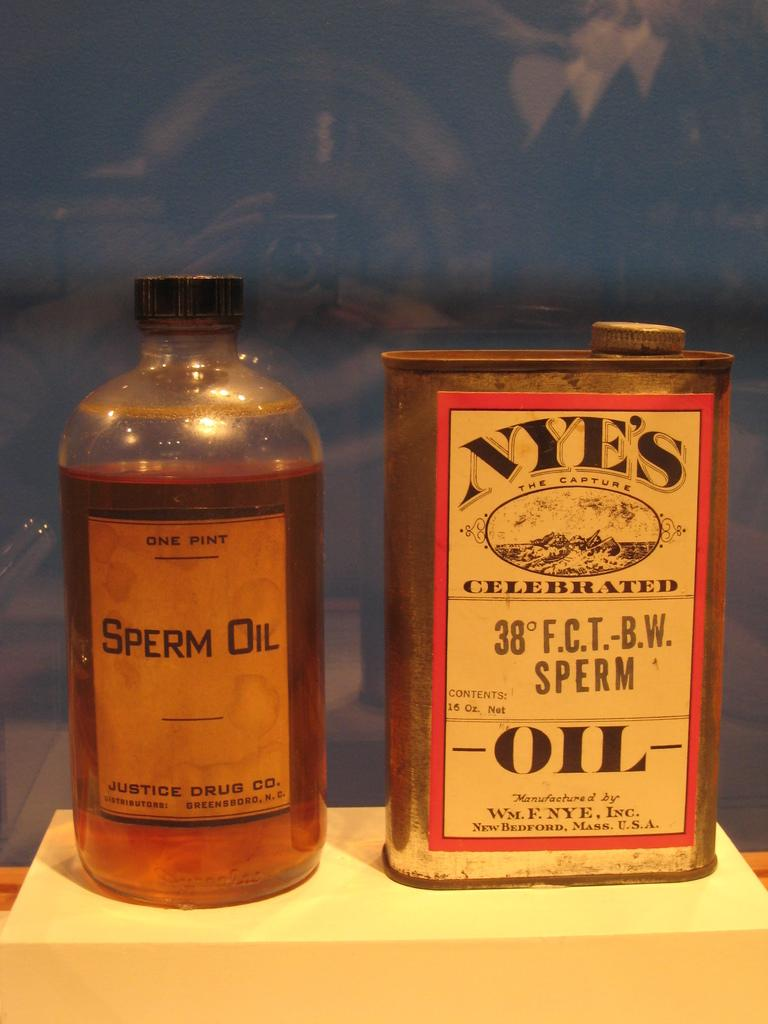Provide a one-sentence caption for the provided image. The bottle on the right has the words Sperm Oil written on it. 